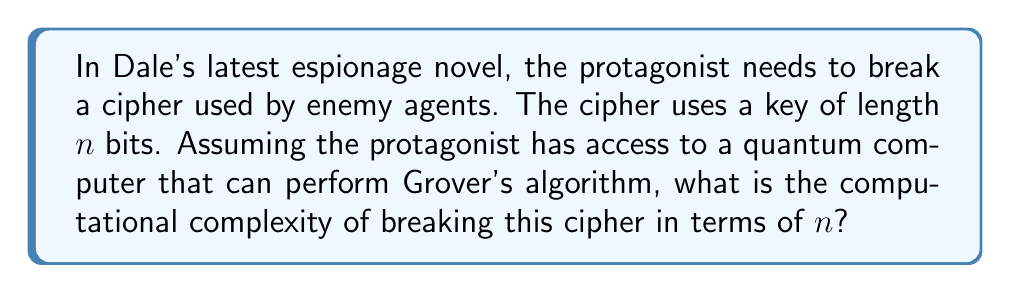Give your solution to this math problem. To solve this problem, we need to consider the following steps:

1) In classical computing, breaking a cipher with a key length of $n$ bits typically requires trying all possible keys, which is $2^n$ operations in the worst case. This gives a computational complexity of $O(2^n)$.

2) However, the question mentions a quantum computer capable of running Grover's algorithm. Grover's algorithm is a quantum algorithm for searching an unsorted database with $N$ entries in $O(\sqrt{N})$ time.

3) In our case, the "database" is the set of all possible keys, which has size $N = 2^n$.

4) Applying Grover's algorithm to this problem, we can find the correct key in:

   $$O(\sqrt{2^n}) = O(2^{n/2})$$

5) This is because:
   $$\sqrt{2^n} = (2^n)^{1/2} = 2^{n/2}$$

6) The computational complexity is therefore $O(2^{n/2})$, which is a quadratic speedup over the classical approach.

This result showcases the power of quantum computing in cryptanalysis, a theme that would fit well in an espionage novel. It demonstrates why quantum-resistant encryption is becoming increasingly important in the real world of cybersecurity.
Answer: $O(2^{n/2})$ 